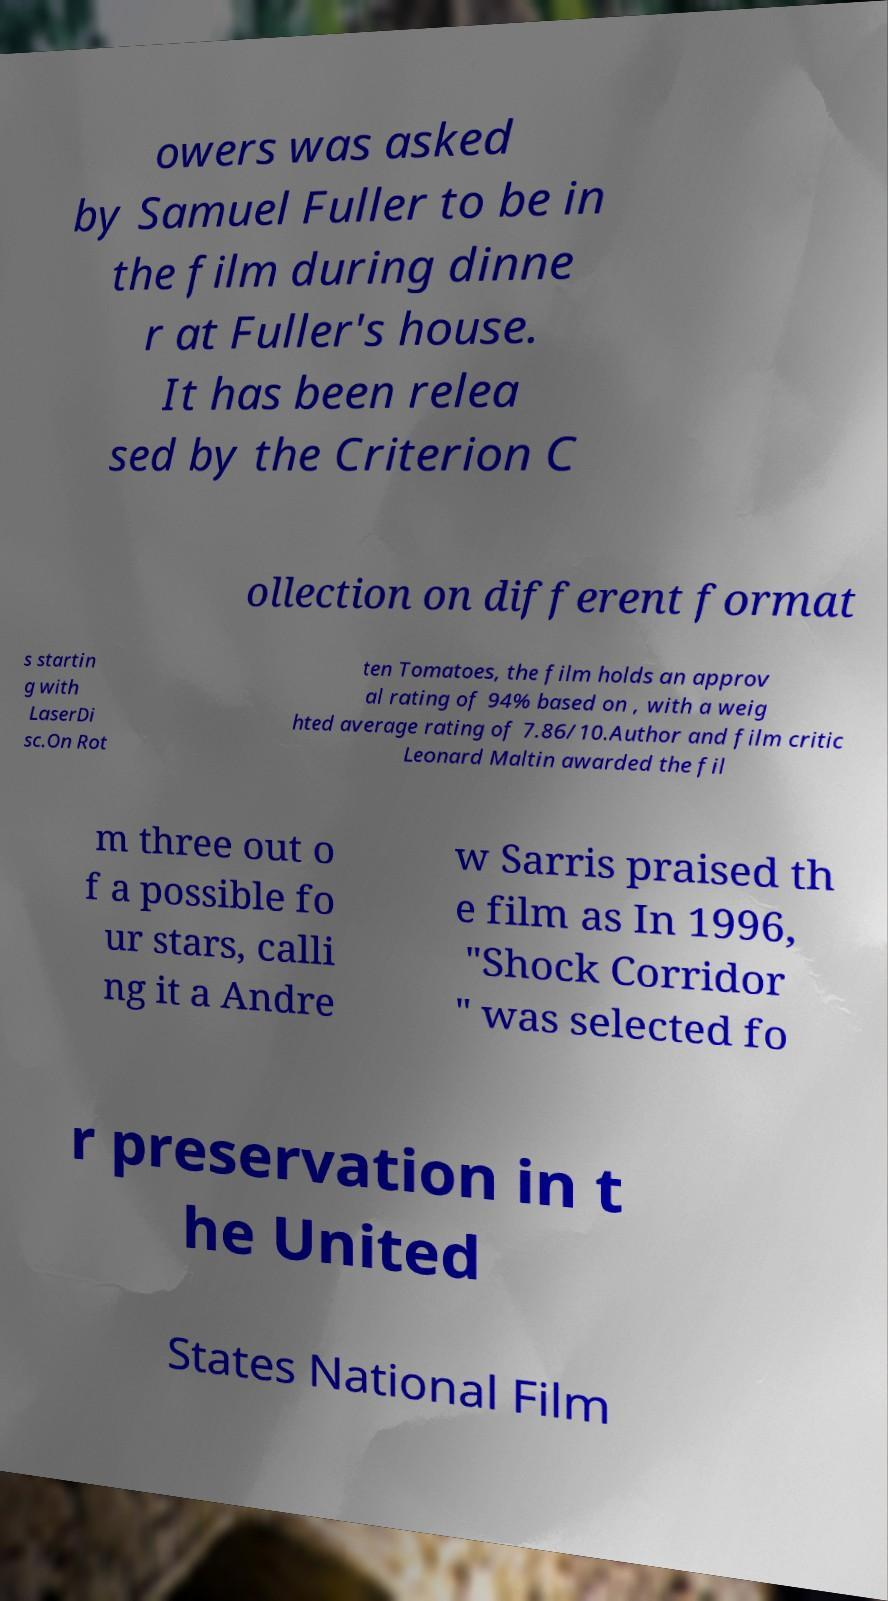What messages or text are displayed in this image? I need them in a readable, typed format. owers was asked by Samuel Fuller to be in the film during dinne r at Fuller's house. It has been relea sed by the Criterion C ollection on different format s startin g with LaserDi sc.On Rot ten Tomatoes, the film holds an approv al rating of 94% based on , with a weig hted average rating of 7.86/10.Author and film critic Leonard Maltin awarded the fil m three out o f a possible fo ur stars, calli ng it a Andre w Sarris praised th e film as In 1996, "Shock Corridor " was selected fo r preservation in t he United States National Film 